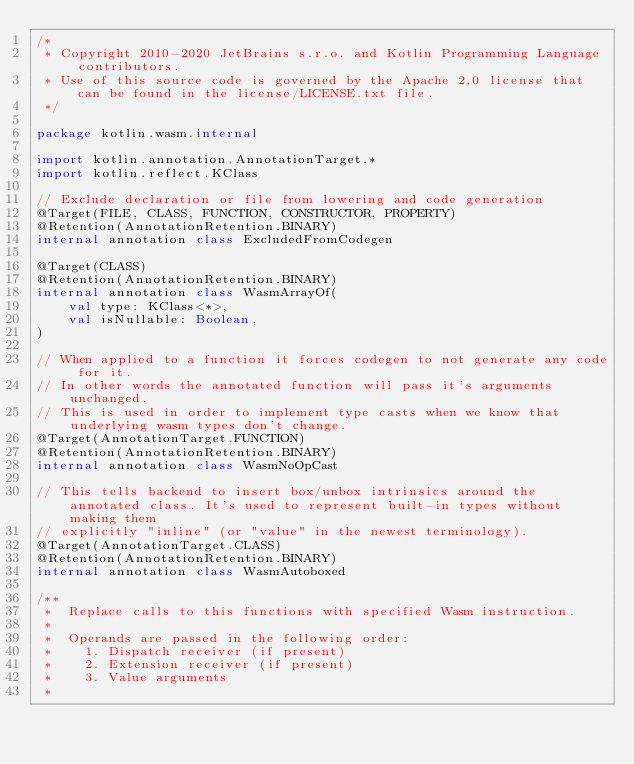<code> <loc_0><loc_0><loc_500><loc_500><_Kotlin_>/*
 * Copyright 2010-2020 JetBrains s.r.o. and Kotlin Programming Language contributors.
 * Use of this source code is governed by the Apache 2.0 license that can be found in the license/LICENSE.txt file.
 */

package kotlin.wasm.internal

import kotlin.annotation.AnnotationTarget.*
import kotlin.reflect.KClass

// Exclude declaration or file from lowering and code generation
@Target(FILE, CLASS, FUNCTION, CONSTRUCTOR, PROPERTY)
@Retention(AnnotationRetention.BINARY)
internal annotation class ExcludedFromCodegen

@Target(CLASS)
@Retention(AnnotationRetention.BINARY)
internal annotation class WasmArrayOf(
    val type: KClass<*>,
    val isNullable: Boolean,
)

// When applied to a function it forces codegen to not generate any code for it.
// In other words the annotated function will pass it's arguments unchanged.
// This is used in order to implement type casts when we know that underlying wasm types don't change.
@Target(AnnotationTarget.FUNCTION)
@Retention(AnnotationRetention.BINARY)
internal annotation class WasmNoOpCast

// This tells backend to insert box/unbox intrinsics around the annotated class. It's used to represent built-in types without making them
// explicitly "inline" (or "value" in the newest terminology).
@Target(AnnotationTarget.CLASS)
@Retention(AnnotationRetention.BINARY)
internal annotation class WasmAutoboxed

/**
 *  Replace calls to this functions with specified Wasm instruction.
 *
 *  Operands are passed in the following order:
 *    1. Dispatch receiver (if present)
 *    2. Extension receiver (if present)
 *    3. Value arguments
 *</code> 